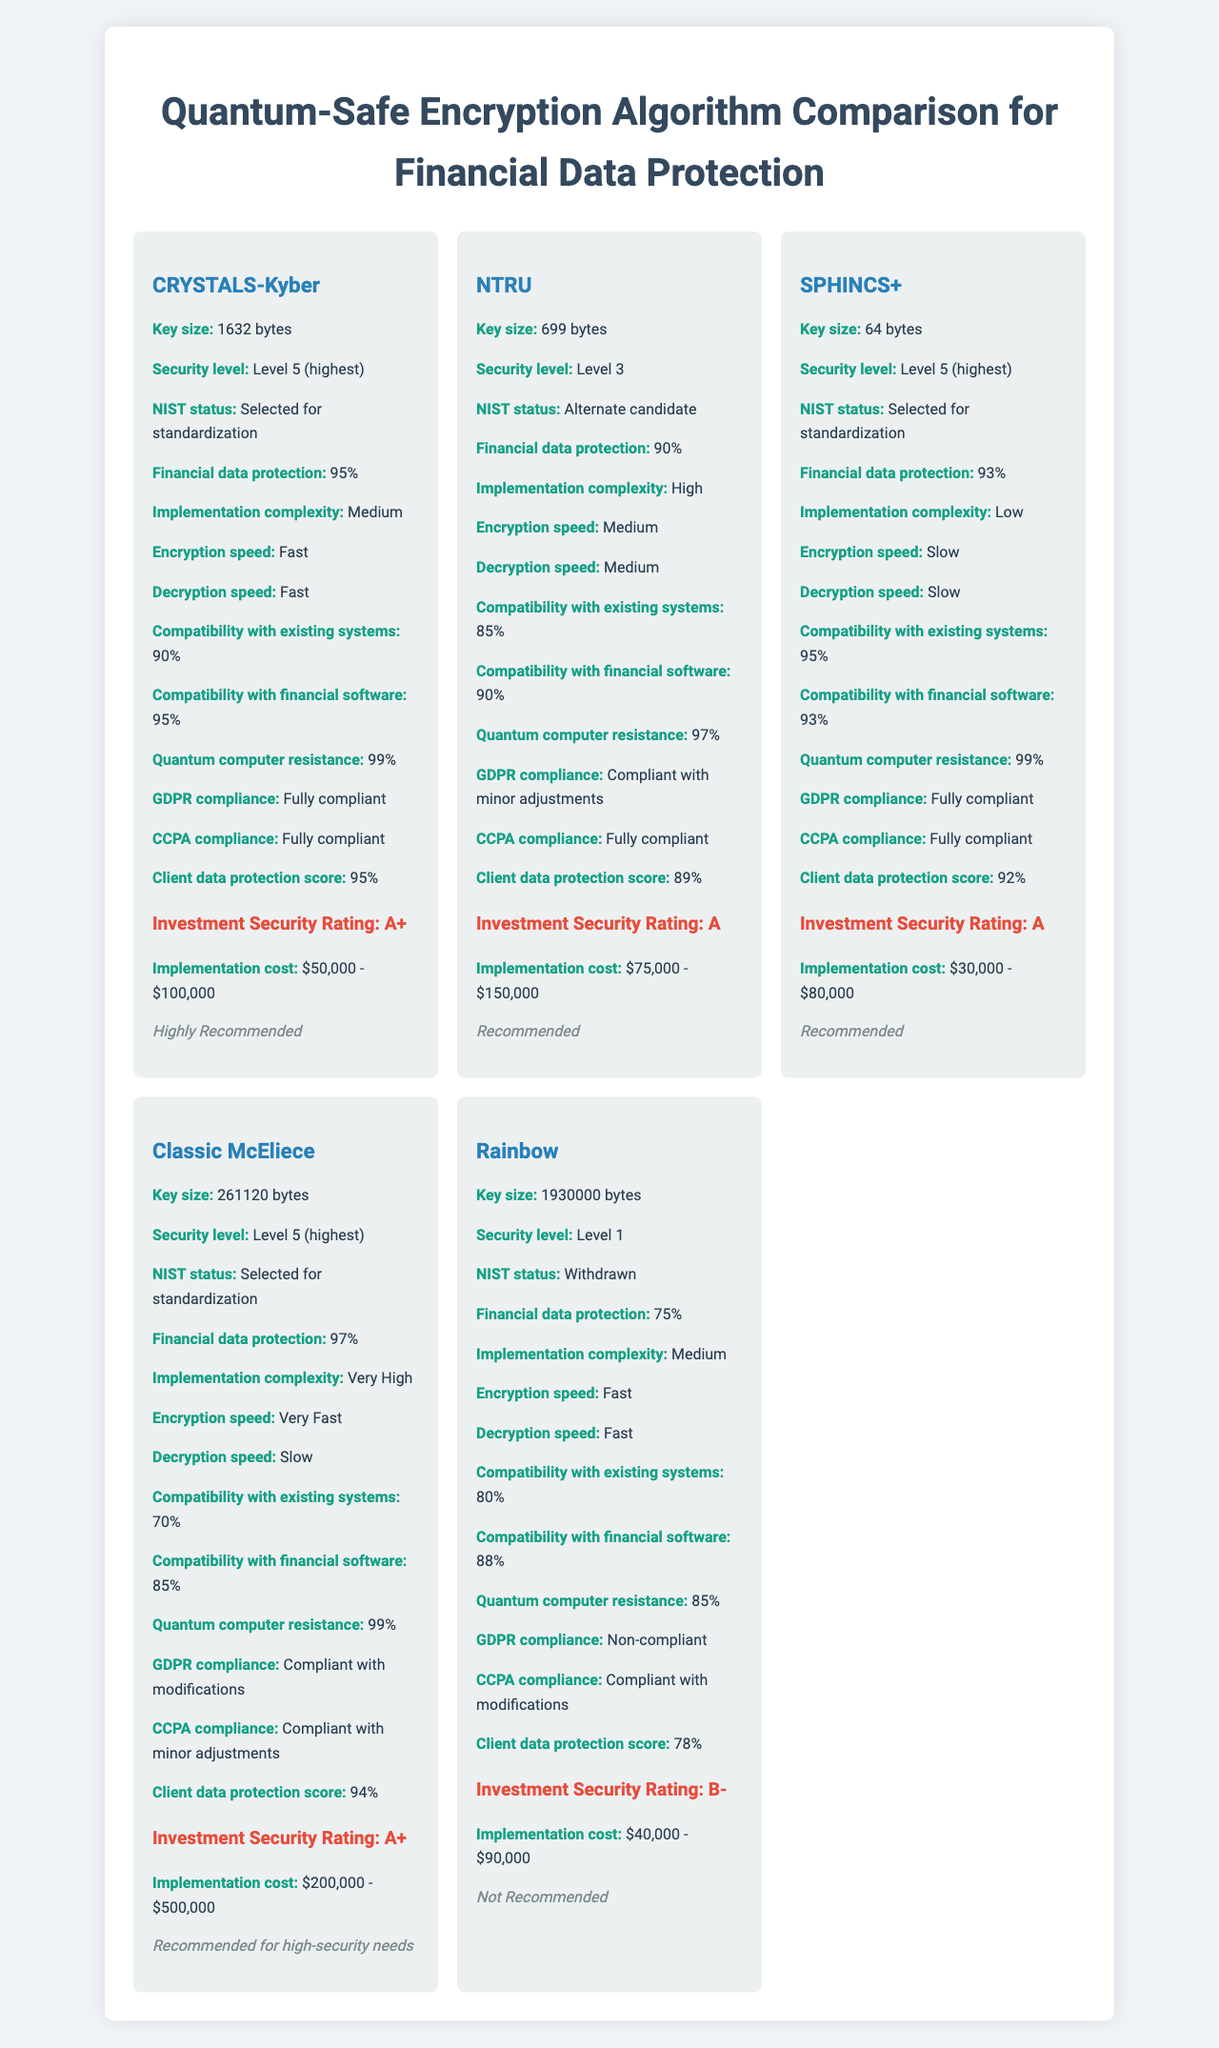what is the serving size? The serving size is listed at the top of the document as "256-bit encryption key".
Answer: 256-bit encryption key how many servings are there per container? The document states "Servings Per Container: Unlimited" at the top of the document.
Answer: Unlimited which algorithm has the highest key size? According to the document, Rainbow has a key size of 1,930,000 bytes, which is the largest among the algorithms listed.
Answer: Rainbow is Rainbow recommended for financial advisors? The document states "Rainbow: Not Recommended" under the section "Recommended for Financial Advisors".
Answer: No what is the estimated security level of CRYSTALS-Kyber? The security level for CRYSTALS-Kyber is specified as "Level 5 (highest)" in the document.
Answer: Level 5 (highest) which of the following algorithms is fully compliant with GDPR? A. CRYSTALS-Kyber B. NTRU C. Classic McEliece D. Rainbow The document lists only CRYSTALS-Kyber and SPHINCS+ as "Fully compliant" with GDPR. Among the options provided, CRYSTALS-Kyber is the correct one.
Answer: A which algorithm has the slowest decryption speed? 1. CRYSTALS-Kyber 2. NTRU 3. SPHINCS+ 4. Classic McEliece The document mentions SPHINCS+ has a "Slow" decryption speed, which is the slowest rating among the listed algorithms.
Answer: 3 is Classic McEliece selected for standardization by NIST? The document lists Classic McEliece's NIST status as "Selected for standardization".
Answer: Yes summarize the main idea of this document. The document provides a detailed overview of various quantum-safe encryption algorithms, including information on key sizes, security levels, financial data protection, implementation complexities, performance metrics, compatibility with systems, regulatory compliance, client data protection scores, investment security ratings, implementation costs, and recommendations tailored specifically for financial advisors.
Answer: The document compares quantum-safe encryption algorithms for protecting financial data, listing their key sizes, security levels, financial data protection ratings, implementation complexities, performance metrics, compatibility with existing systems, regulatory compliance, client data protection scores, investment security ratings, implementation costs, and recommendations for financial advisors. what is the financial data protection percentage for CRYSTALS-Kyber? The financial data protection for CRYSTALS-Kyber is listed as 95% in the document.
Answer: 95% which algorithm has a higher compatibility with financial software, SPHINCS+ or NTRU? SPHINCS+ has a compatibility rating of 93% with financial software, while NTRU has a rating of 90%, making SPHINCS+ higher.
Answer: SPHINCS+ what is the CCPA compliance status of SPHINCS+? The document states that SPHINCS+ is "Fully compliant" with CCPA.
Answer: Fully compliant cannot be determined from the document provided? The document does not provide information about the implementation time for any of the quantum-safe algorithms.
Answer: What is the average implementation time for these quantum-safe algorithms? 